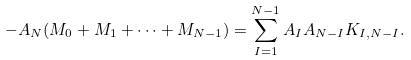Convert formula to latex. <formula><loc_0><loc_0><loc_500><loc_500>- A _ { N } ( M _ { 0 } + M _ { 1 } + \dots + M _ { N - 1 } ) = \sum _ { I = 1 } ^ { N - 1 } A _ { I } A _ { N - I } K _ { I , N - I } .</formula> 